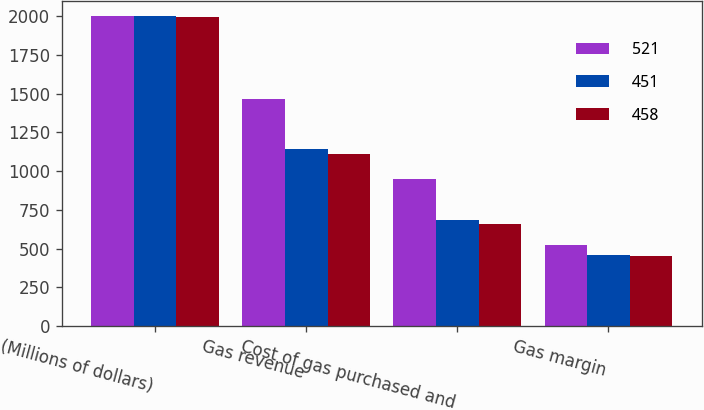Convert chart. <chart><loc_0><loc_0><loc_500><loc_500><stacked_bar_chart><ecel><fcel>(Millions of dollars)<fcel>Gas revenue<fcel>Cost of gas purchased and<fcel>Gas margin<nl><fcel>521<fcel>2000<fcel>1469<fcel>948<fcel>521<nl><fcel>451<fcel>1999<fcel>1141<fcel>683<fcel>458<nl><fcel>458<fcel>1998<fcel>1110<fcel>659<fcel>451<nl></chart> 